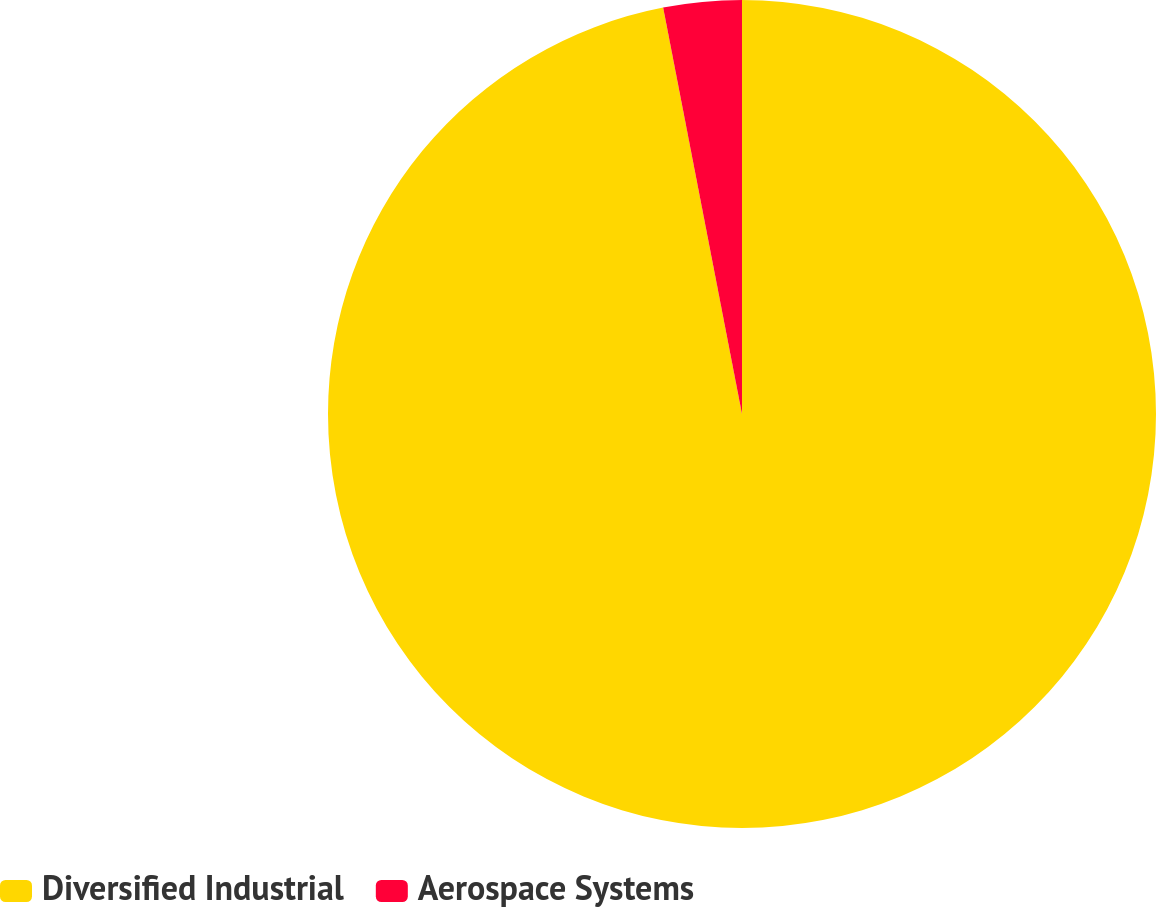<chart> <loc_0><loc_0><loc_500><loc_500><pie_chart><fcel>Diversified Industrial<fcel>Aerospace Systems<nl><fcel>96.95%<fcel>3.05%<nl></chart> 